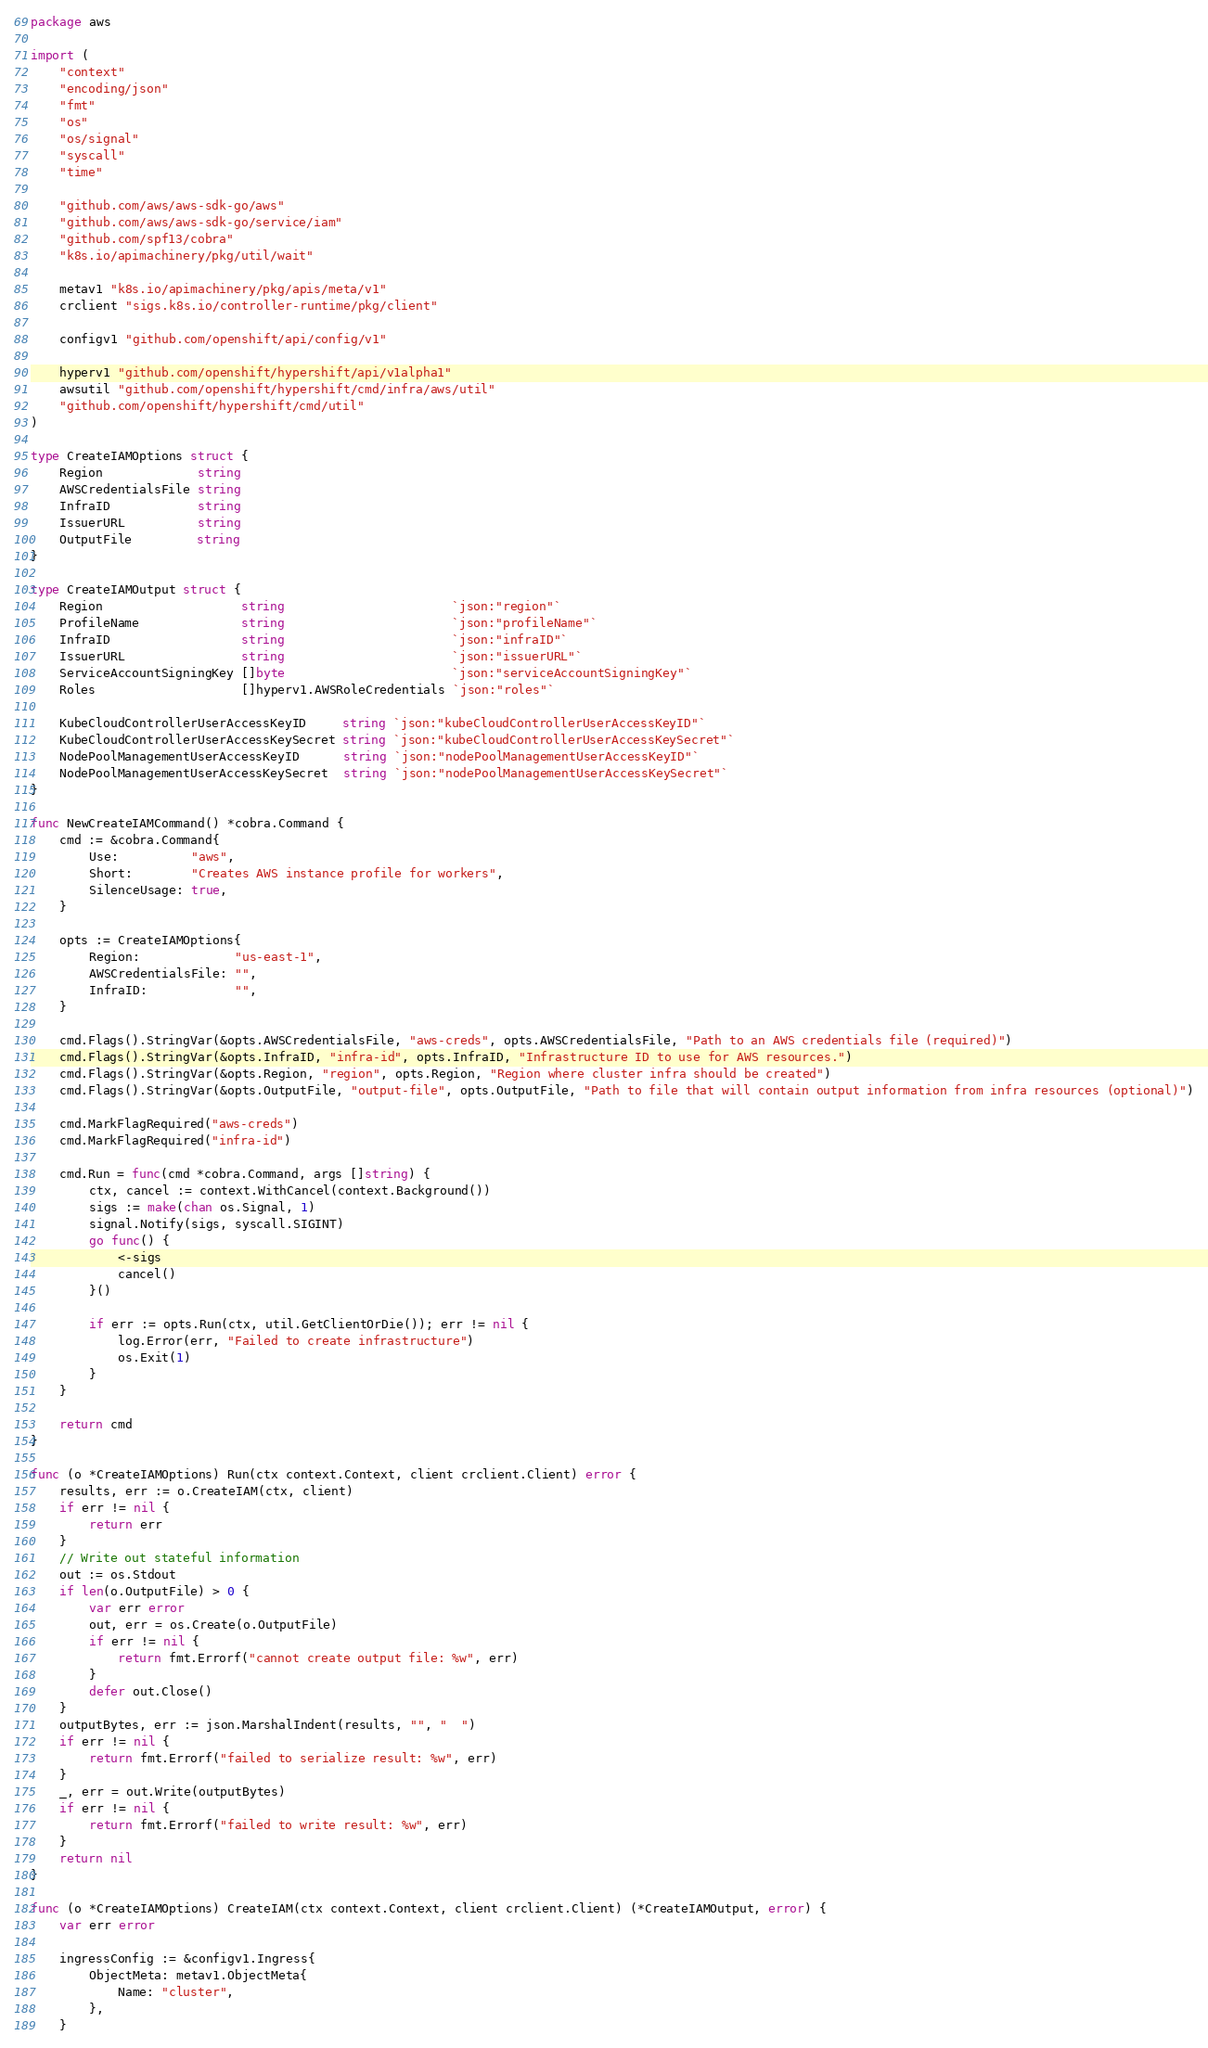Convert code to text. <code><loc_0><loc_0><loc_500><loc_500><_Go_>package aws

import (
	"context"
	"encoding/json"
	"fmt"
	"os"
	"os/signal"
	"syscall"
	"time"

	"github.com/aws/aws-sdk-go/aws"
	"github.com/aws/aws-sdk-go/service/iam"
	"github.com/spf13/cobra"
	"k8s.io/apimachinery/pkg/util/wait"

	metav1 "k8s.io/apimachinery/pkg/apis/meta/v1"
	crclient "sigs.k8s.io/controller-runtime/pkg/client"

	configv1 "github.com/openshift/api/config/v1"

	hyperv1 "github.com/openshift/hypershift/api/v1alpha1"
	awsutil "github.com/openshift/hypershift/cmd/infra/aws/util"
	"github.com/openshift/hypershift/cmd/util"
)

type CreateIAMOptions struct {
	Region             string
	AWSCredentialsFile string
	InfraID            string
	IssuerURL          string
	OutputFile         string
}

type CreateIAMOutput struct {
	Region                   string                       `json:"region"`
	ProfileName              string                       `json:"profileName"`
	InfraID                  string                       `json:"infraID"`
	IssuerURL                string                       `json:"issuerURL"`
	ServiceAccountSigningKey []byte                       `json:"serviceAccountSigningKey"`
	Roles                    []hyperv1.AWSRoleCredentials `json:"roles"`

	KubeCloudControllerUserAccessKeyID     string `json:"kubeCloudControllerUserAccessKeyID"`
	KubeCloudControllerUserAccessKeySecret string `json:"kubeCloudControllerUserAccessKeySecret"`
	NodePoolManagementUserAccessKeyID      string `json:"nodePoolManagementUserAccessKeyID"`
	NodePoolManagementUserAccessKeySecret  string `json:"nodePoolManagementUserAccessKeySecret"`
}

func NewCreateIAMCommand() *cobra.Command {
	cmd := &cobra.Command{
		Use:          "aws",
		Short:        "Creates AWS instance profile for workers",
		SilenceUsage: true,
	}

	opts := CreateIAMOptions{
		Region:             "us-east-1",
		AWSCredentialsFile: "",
		InfraID:            "",
	}

	cmd.Flags().StringVar(&opts.AWSCredentialsFile, "aws-creds", opts.AWSCredentialsFile, "Path to an AWS credentials file (required)")
	cmd.Flags().StringVar(&opts.InfraID, "infra-id", opts.InfraID, "Infrastructure ID to use for AWS resources.")
	cmd.Flags().StringVar(&opts.Region, "region", opts.Region, "Region where cluster infra should be created")
	cmd.Flags().StringVar(&opts.OutputFile, "output-file", opts.OutputFile, "Path to file that will contain output information from infra resources (optional)")

	cmd.MarkFlagRequired("aws-creds")
	cmd.MarkFlagRequired("infra-id")

	cmd.Run = func(cmd *cobra.Command, args []string) {
		ctx, cancel := context.WithCancel(context.Background())
		sigs := make(chan os.Signal, 1)
		signal.Notify(sigs, syscall.SIGINT)
		go func() {
			<-sigs
			cancel()
		}()

		if err := opts.Run(ctx, util.GetClientOrDie()); err != nil {
			log.Error(err, "Failed to create infrastructure")
			os.Exit(1)
		}
	}

	return cmd
}

func (o *CreateIAMOptions) Run(ctx context.Context, client crclient.Client) error {
	results, err := o.CreateIAM(ctx, client)
	if err != nil {
		return err
	}
	// Write out stateful information
	out := os.Stdout
	if len(o.OutputFile) > 0 {
		var err error
		out, err = os.Create(o.OutputFile)
		if err != nil {
			return fmt.Errorf("cannot create output file: %w", err)
		}
		defer out.Close()
	}
	outputBytes, err := json.MarshalIndent(results, "", "  ")
	if err != nil {
		return fmt.Errorf("failed to serialize result: %w", err)
	}
	_, err = out.Write(outputBytes)
	if err != nil {
		return fmt.Errorf("failed to write result: %w", err)
	}
	return nil
}

func (o *CreateIAMOptions) CreateIAM(ctx context.Context, client crclient.Client) (*CreateIAMOutput, error) {
	var err error

	ingressConfig := &configv1.Ingress{
		ObjectMeta: metav1.ObjectMeta{
			Name: "cluster",
		},
	}
</code> 